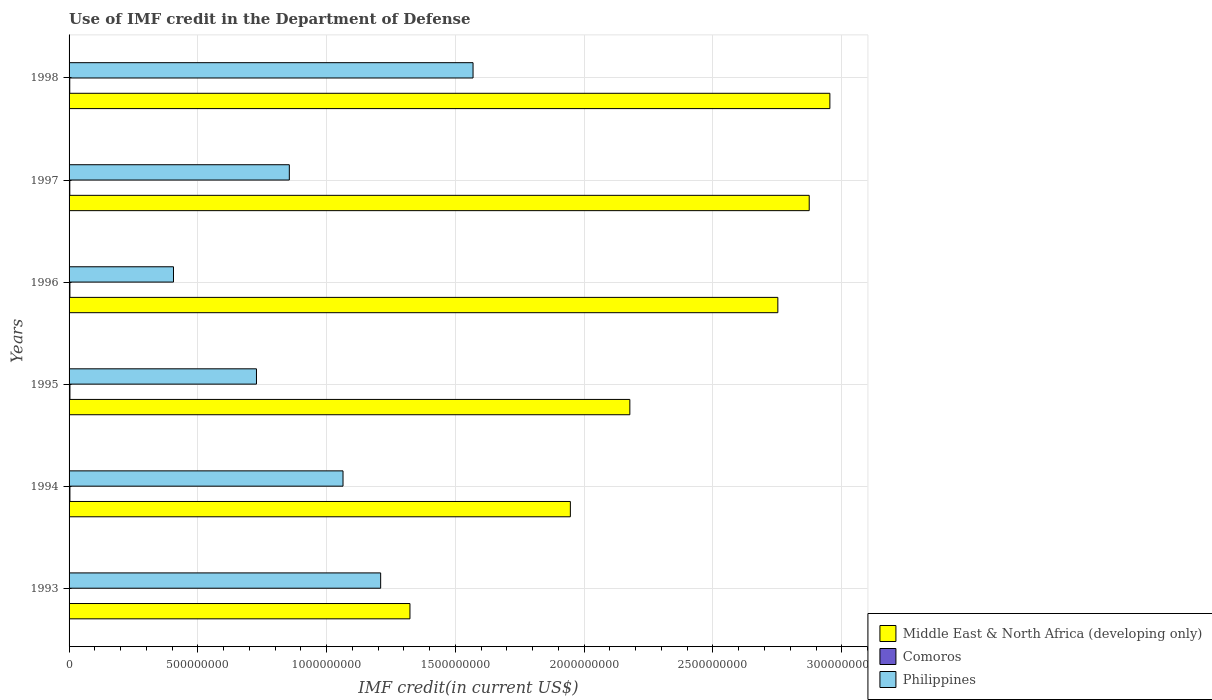How many different coloured bars are there?
Keep it short and to the point. 3. How many groups of bars are there?
Your answer should be compact. 6. Are the number of bars per tick equal to the number of legend labels?
Make the answer very short. Yes. Are the number of bars on each tick of the Y-axis equal?
Give a very brief answer. Yes. How many bars are there on the 4th tick from the top?
Your answer should be very brief. 3. In how many cases, is the number of bars for a given year not equal to the number of legend labels?
Keep it short and to the point. 0. What is the IMF credit in the Department of Defense in Comoros in 1995?
Give a very brief answer. 3.34e+06. Across all years, what is the maximum IMF credit in the Department of Defense in Philippines?
Give a very brief answer. 1.57e+09. Across all years, what is the minimum IMF credit in the Department of Defense in Middle East & North Africa (developing only)?
Keep it short and to the point. 1.32e+09. In which year was the IMF credit in the Department of Defense in Comoros minimum?
Give a very brief answer. 1993. What is the total IMF credit in the Department of Defense in Comoros in the graph?
Provide a succinct answer. 1.66e+07. What is the difference between the IMF credit in the Department of Defense in Comoros in 1995 and that in 1996?
Give a very brief answer. 1.10e+05. What is the difference between the IMF credit in the Department of Defense in Middle East & North Africa (developing only) in 1997 and the IMF credit in the Department of Defense in Philippines in 1998?
Give a very brief answer. 1.31e+09. What is the average IMF credit in the Department of Defense in Philippines per year?
Your response must be concise. 9.72e+08. In the year 1993, what is the difference between the IMF credit in the Department of Defense in Middle East & North Africa (developing only) and IMF credit in the Department of Defense in Comoros?
Your answer should be very brief. 1.32e+09. What is the ratio of the IMF credit in the Department of Defense in Philippines in 1993 to that in 1998?
Ensure brevity in your answer.  0.77. What is the difference between the highest and the second highest IMF credit in the Department of Defense in Philippines?
Make the answer very short. 3.59e+08. What is the difference between the highest and the lowest IMF credit in the Department of Defense in Philippines?
Offer a terse response. 1.16e+09. In how many years, is the IMF credit in the Department of Defense in Comoros greater than the average IMF credit in the Department of Defense in Comoros taken over all years?
Offer a terse response. 4. What does the 1st bar from the bottom in 1994 represents?
Your answer should be very brief. Middle East & North Africa (developing only). Is it the case that in every year, the sum of the IMF credit in the Department of Defense in Middle East & North Africa (developing only) and IMF credit in the Department of Defense in Comoros is greater than the IMF credit in the Department of Defense in Philippines?
Offer a very short reply. Yes. Are all the bars in the graph horizontal?
Give a very brief answer. Yes. How many years are there in the graph?
Give a very brief answer. 6. What is the difference between two consecutive major ticks on the X-axis?
Provide a short and direct response. 5.00e+08. Does the graph contain grids?
Your answer should be compact. Yes. Where does the legend appear in the graph?
Make the answer very short. Bottom right. How are the legend labels stacked?
Provide a short and direct response. Vertical. What is the title of the graph?
Your answer should be very brief. Use of IMF credit in the Department of Defense. What is the label or title of the X-axis?
Ensure brevity in your answer.  IMF credit(in current US$). What is the IMF credit(in current US$) in Middle East & North Africa (developing only) in 1993?
Your answer should be very brief. 1.32e+09. What is the IMF credit(in current US$) of Comoros in 1993?
Make the answer very short. 1.24e+06. What is the IMF credit(in current US$) of Philippines in 1993?
Ensure brevity in your answer.  1.21e+09. What is the IMF credit(in current US$) in Middle East & North Africa (developing only) in 1994?
Give a very brief answer. 1.95e+09. What is the IMF credit(in current US$) of Comoros in 1994?
Offer a terse response. 3.28e+06. What is the IMF credit(in current US$) of Philippines in 1994?
Provide a short and direct response. 1.06e+09. What is the IMF credit(in current US$) in Middle East & North Africa (developing only) in 1995?
Your response must be concise. 2.18e+09. What is the IMF credit(in current US$) in Comoros in 1995?
Keep it short and to the point. 3.34e+06. What is the IMF credit(in current US$) in Philippines in 1995?
Your response must be concise. 7.28e+08. What is the IMF credit(in current US$) in Middle East & North Africa (developing only) in 1996?
Keep it short and to the point. 2.75e+09. What is the IMF credit(in current US$) of Comoros in 1996?
Make the answer very short. 3.24e+06. What is the IMF credit(in current US$) in Philippines in 1996?
Your response must be concise. 4.05e+08. What is the IMF credit(in current US$) in Middle East & North Africa (developing only) in 1997?
Make the answer very short. 2.87e+09. What is the IMF credit(in current US$) of Comoros in 1997?
Make the answer very short. 2.79e+06. What is the IMF credit(in current US$) of Philippines in 1997?
Keep it short and to the point. 8.55e+08. What is the IMF credit(in current US$) of Middle East & North Africa (developing only) in 1998?
Offer a very short reply. 2.95e+09. What is the IMF credit(in current US$) of Comoros in 1998?
Give a very brief answer. 2.66e+06. What is the IMF credit(in current US$) of Philippines in 1998?
Your response must be concise. 1.57e+09. Across all years, what is the maximum IMF credit(in current US$) of Middle East & North Africa (developing only)?
Give a very brief answer. 2.95e+09. Across all years, what is the maximum IMF credit(in current US$) in Comoros?
Provide a succinct answer. 3.34e+06. Across all years, what is the maximum IMF credit(in current US$) of Philippines?
Keep it short and to the point. 1.57e+09. Across all years, what is the minimum IMF credit(in current US$) in Middle East & North Africa (developing only)?
Make the answer very short. 1.32e+09. Across all years, what is the minimum IMF credit(in current US$) in Comoros?
Offer a terse response. 1.24e+06. Across all years, what is the minimum IMF credit(in current US$) in Philippines?
Provide a short and direct response. 4.05e+08. What is the total IMF credit(in current US$) in Middle East & North Africa (developing only) in the graph?
Provide a succinct answer. 1.40e+1. What is the total IMF credit(in current US$) of Comoros in the graph?
Offer a very short reply. 1.66e+07. What is the total IMF credit(in current US$) in Philippines in the graph?
Keep it short and to the point. 5.83e+09. What is the difference between the IMF credit(in current US$) of Middle East & North Africa (developing only) in 1993 and that in 1994?
Keep it short and to the point. -6.23e+08. What is the difference between the IMF credit(in current US$) of Comoros in 1993 and that in 1994?
Offer a very short reply. -2.05e+06. What is the difference between the IMF credit(in current US$) of Philippines in 1993 and that in 1994?
Your answer should be very brief. 1.46e+08. What is the difference between the IMF credit(in current US$) of Middle East & North Africa (developing only) in 1993 and that in 1995?
Your answer should be very brief. -8.54e+08. What is the difference between the IMF credit(in current US$) in Comoros in 1993 and that in 1995?
Your answer should be very brief. -2.11e+06. What is the difference between the IMF credit(in current US$) of Philippines in 1993 and that in 1995?
Your answer should be very brief. 4.82e+08. What is the difference between the IMF credit(in current US$) of Middle East & North Africa (developing only) in 1993 and that in 1996?
Your answer should be compact. -1.43e+09. What is the difference between the IMF credit(in current US$) of Comoros in 1993 and that in 1996?
Offer a very short reply. -2.00e+06. What is the difference between the IMF credit(in current US$) of Philippines in 1993 and that in 1996?
Provide a short and direct response. 8.04e+08. What is the difference between the IMF credit(in current US$) in Middle East & North Africa (developing only) in 1993 and that in 1997?
Offer a very short reply. -1.55e+09. What is the difference between the IMF credit(in current US$) in Comoros in 1993 and that in 1997?
Your response must be concise. -1.56e+06. What is the difference between the IMF credit(in current US$) in Philippines in 1993 and that in 1997?
Offer a terse response. 3.55e+08. What is the difference between the IMF credit(in current US$) of Middle East & North Africa (developing only) in 1993 and that in 1998?
Provide a short and direct response. -1.63e+09. What is the difference between the IMF credit(in current US$) in Comoros in 1993 and that in 1998?
Your answer should be compact. -1.42e+06. What is the difference between the IMF credit(in current US$) in Philippines in 1993 and that in 1998?
Give a very brief answer. -3.59e+08. What is the difference between the IMF credit(in current US$) in Middle East & North Africa (developing only) in 1994 and that in 1995?
Your answer should be compact. -2.31e+08. What is the difference between the IMF credit(in current US$) in Philippines in 1994 and that in 1995?
Provide a short and direct response. 3.36e+08. What is the difference between the IMF credit(in current US$) in Middle East & North Africa (developing only) in 1994 and that in 1996?
Make the answer very short. -8.06e+08. What is the difference between the IMF credit(in current US$) in Philippines in 1994 and that in 1996?
Keep it short and to the point. 6.58e+08. What is the difference between the IMF credit(in current US$) of Middle East & North Africa (developing only) in 1994 and that in 1997?
Provide a succinct answer. -9.27e+08. What is the difference between the IMF credit(in current US$) of Comoros in 1994 and that in 1997?
Make the answer very short. 4.92e+05. What is the difference between the IMF credit(in current US$) in Philippines in 1994 and that in 1997?
Your response must be concise. 2.08e+08. What is the difference between the IMF credit(in current US$) of Middle East & North Africa (developing only) in 1994 and that in 1998?
Offer a very short reply. -1.01e+09. What is the difference between the IMF credit(in current US$) of Comoros in 1994 and that in 1998?
Provide a short and direct response. 6.24e+05. What is the difference between the IMF credit(in current US$) of Philippines in 1994 and that in 1998?
Offer a terse response. -5.05e+08. What is the difference between the IMF credit(in current US$) of Middle East & North Africa (developing only) in 1995 and that in 1996?
Your answer should be very brief. -5.75e+08. What is the difference between the IMF credit(in current US$) of Comoros in 1995 and that in 1996?
Ensure brevity in your answer.  1.10e+05. What is the difference between the IMF credit(in current US$) in Philippines in 1995 and that in 1996?
Give a very brief answer. 3.22e+08. What is the difference between the IMF credit(in current US$) of Middle East & North Africa (developing only) in 1995 and that in 1997?
Offer a very short reply. -6.96e+08. What is the difference between the IMF credit(in current US$) in Comoros in 1995 and that in 1997?
Make the answer very short. 5.52e+05. What is the difference between the IMF credit(in current US$) of Philippines in 1995 and that in 1997?
Your answer should be very brief. -1.28e+08. What is the difference between the IMF credit(in current US$) of Middle East & North Africa (developing only) in 1995 and that in 1998?
Your response must be concise. -7.77e+08. What is the difference between the IMF credit(in current US$) of Comoros in 1995 and that in 1998?
Provide a short and direct response. 6.84e+05. What is the difference between the IMF credit(in current US$) in Philippines in 1995 and that in 1998?
Your answer should be very brief. -8.41e+08. What is the difference between the IMF credit(in current US$) of Middle East & North Africa (developing only) in 1996 and that in 1997?
Provide a short and direct response. -1.22e+08. What is the difference between the IMF credit(in current US$) in Comoros in 1996 and that in 1997?
Offer a terse response. 4.42e+05. What is the difference between the IMF credit(in current US$) in Philippines in 1996 and that in 1997?
Provide a short and direct response. -4.50e+08. What is the difference between the IMF credit(in current US$) of Middle East & North Africa (developing only) in 1996 and that in 1998?
Make the answer very short. -2.02e+08. What is the difference between the IMF credit(in current US$) of Comoros in 1996 and that in 1998?
Your response must be concise. 5.74e+05. What is the difference between the IMF credit(in current US$) in Philippines in 1996 and that in 1998?
Make the answer very short. -1.16e+09. What is the difference between the IMF credit(in current US$) in Middle East & North Africa (developing only) in 1997 and that in 1998?
Your answer should be compact. -8.02e+07. What is the difference between the IMF credit(in current US$) of Comoros in 1997 and that in 1998?
Offer a terse response. 1.32e+05. What is the difference between the IMF credit(in current US$) in Philippines in 1997 and that in 1998?
Your answer should be very brief. -7.13e+08. What is the difference between the IMF credit(in current US$) in Middle East & North Africa (developing only) in 1993 and the IMF credit(in current US$) in Comoros in 1994?
Provide a succinct answer. 1.32e+09. What is the difference between the IMF credit(in current US$) of Middle East & North Africa (developing only) in 1993 and the IMF credit(in current US$) of Philippines in 1994?
Your answer should be compact. 2.60e+08. What is the difference between the IMF credit(in current US$) of Comoros in 1993 and the IMF credit(in current US$) of Philippines in 1994?
Give a very brief answer. -1.06e+09. What is the difference between the IMF credit(in current US$) in Middle East & North Africa (developing only) in 1993 and the IMF credit(in current US$) in Comoros in 1995?
Offer a very short reply. 1.32e+09. What is the difference between the IMF credit(in current US$) in Middle East & North Africa (developing only) in 1993 and the IMF credit(in current US$) in Philippines in 1995?
Your answer should be very brief. 5.96e+08. What is the difference between the IMF credit(in current US$) in Comoros in 1993 and the IMF credit(in current US$) in Philippines in 1995?
Offer a very short reply. -7.26e+08. What is the difference between the IMF credit(in current US$) in Middle East & North Africa (developing only) in 1993 and the IMF credit(in current US$) in Comoros in 1996?
Keep it short and to the point. 1.32e+09. What is the difference between the IMF credit(in current US$) of Middle East & North Africa (developing only) in 1993 and the IMF credit(in current US$) of Philippines in 1996?
Offer a terse response. 9.18e+08. What is the difference between the IMF credit(in current US$) of Comoros in 1993 and the IMF credit(in current US$) of Philippines in 1996?
Give a very brief answer. -4.04e+08. What is the difference between the IMF credit(in current US$) in Middle East & North Africa (developing only) in 1993 and the IMF credit(in current US$) in Comoros in 1997?
Keep it short and to the point. 1.32e+09. What is the difference between the IMF credit(in current US$) in Middle East & North Africa (developing only) in 1993 and the IMF credit(in current US$) in Philippines in 1997?
Give a very brief answer. 4.68e+08. What is the difference between the IMF credit(in current US$) in Comoros in 1993 and the IMF credit(in current US$) in Philippines in 1997?
Your answer should be very brief. -8.54e+08. What is the difference between the IMF credit(in current US$) in Middle East & North Africa (developing only) in 1993 and the IMF credit(in current US$) in Comoros in 1998?
Keep it short and to the point. 1.32e+09. What is the difference between the IMF credit(in current US$) of Middle East & North Africa (developing only) in 1993 and the IMF credit(in current US$) of Philippines in 1998?
Ensure brevity in your answer.  -2.45e+08. What is the difference between the IMF credit(in current US$) in Comoros in 1993 and the IMF credit(in current US$) in Philippines in 1998?
Make the answer very short. -1.57e+09. What is the difference between the IMF credit(in current US$) in Middle East & North Africa (developing only) in 1994 and the IMF credit(in current US$) in Comoros in 1995?
Your response must be concise. 1.94e+09. What is the difference between the IMF credit(in current US$) in Middle East & North Africa (developing only) in 1994 and the IMF credit(in current US$) in Philippines in 1995?
Your answer should be very brief. 1.22e+09. What is the difference between the IMF credit(in current US$) in Comoros in 1994 and the IMF credit(in current US$) in Philippines in 1995?
Offer a terse response. -7.24e+08. What is the difference between the IMF credit(in current US$) of Middle East & North Africa (developing only) in 1994 and the IMF credit(in current US$) of Comoros in 1996?
Give a very brief answer. 1.94e+09. What is the difference between the IMF credit(in current US$) of Middle East & North Africa (developing only) in 1994 and the IMF credit(in current US$) of Philippines in 1996?
Provide a succinct answer. 1.54e+09. What is the difference between the IMF credit(in current US$) in Comoros in 1994 and the IMF credit(in current US$) in Philippines in 1996?
Give a very brief answer. -4.02e+08. What is the difference between the IMF credit(in current US$) in Middle East & North Africa (developing only) in 1994 and the IMF credit(in current US$) in Comoros in 1997?
Provide a short and direct response. 1.94e+09. What is the difference between the IMF credit(in current US$) of Middle East & North Africa (developing only) in 1994 and the IMF credit(in current US$) of Philippines in 1997?
Give a very brief answer. 1.09e+09. What is the difference between the IMF credit(in current US$) in Comoros in 1994 and the IMF credit(in current US$) in Philippines in 1997?
Offer a terse response. -8.52e+08. What is the difference between the IMF credit(in current US$) in Middle East & North Africa (developing only) in 1994 and the IMF credit(in current US$) in Comoros in 1998?
Your answer should be very brief. 1.94e+09. What is the difference between the IMF credit(in current US$) in Middle East & North Africa (developing only) in 1994 and the IMF credit(in current US$) in Philippines in 1998?
Offer a terse response. 3.78e+08. What is the difference between the IMF credit(in current US$) of Comoros in 1994 and the IMF credit(in current US$) of Philippines in 1998?
Your answer should be compact. -1.57e+09. What is the difference between the IMF credit(in current US$) of Middle East & North Africa (developing only) in 1995 and the IMF credit(in current US$) of Comoros in 1996?
Ensure brevity in your answer.  2.17e+09. What is the difference between the IMF credit(in current US$) in Middle East & North Africa (developing only) in 1995 and the IMF credit(in current US$) in Philippines in 1996?
Provide a short and direct response. 1.77e+09. What is the difference between the IMF credit(in current US$) of Comoros in 1995 and the IMF credit(in current US$) of Philippines in 1996?
Your answer should be very brief. -4.02e+08. What is the difference between the IMF credit(in current US$) of Middle East & North Africa (developing only) in 1995 and the IMF credit(in current US$) of Comoros in 1997?
Provide a short and direct response. 2.17e+09. What is the difference between the IMF credit(in current US$) in Middle East & North Africa (developing only) in 1995 and the IMF credit(in current US$) in Philippines in 1997?
Give a very brief answer. 1.32e+09. What is the difference between the IMF credit(in current US$) of Comoros in 1995 and the IMF credit(in current US$) of Philippines in 1997?
Offer a very short reply. -8.52e+08. What is the difference between the IMF credit(in current US$) in Middle East & North Africa (developing only) in 1995 and the IMF credit(in current US$) in Comoros in 1998?
Your answer should be compact. 2.17e+09. What is the difference between the IMF credit(in current US$) of Middle East & North Africa (developing only) in 1995 and the IMF credit(in current US$) of Philippines in 1998?
Give a very brief answer. 6.09e+08. What is the difference between the IMF credit(in current US$) in Comoros in 1995 and the IMF credit(in current US$) in Philippines in 1998?
Your answer should be very brief. -1.57e+09. What is the difference between the IMF credit(in current US$) in Middle East & North Africa (developing only) in 1996 and the IMF credit(in current US$) in Comoros in 1997?
Give a very brief answer. 2.75e+09. What is the difference between the IMF credit(in current US$) in Middle East & North Africa (developing only) in 1996 and the IMF credit(in current US$) in Philippines in 1997?
Your answer should be very brief. 1.90e+09. What is the difference between the IMF credit(in current US$) of Comoros in 1996 and the IMF credit(in current US$) of Philippines in 1997?
Provide a succinct answer. -8.52e+08. What is the difference between the IMF credit(in current US$) of Middle East & North Africa (developing only) in 1996 and the IMF credit(in current US$) of Comoros in 1998?
Your answer should be compact. 2.75e+09. What is the difference between the IMF credit(in current US$) of Middle East & North Africa (developing only) in 1996 and the IMF credit(in current US$) of Philippines in 1998?
Ensure brevity in your answer.  1.18e+09. What is the difference between the IMF credit(in current US$) in Comoros in 1996 and the IMF credit(in current US$) in Philippines in 1998?
Your response must be concise. -1.57e+09. What is the difference between the IMF credit(in current US$) of Middle East & North Africa (developing only) in 1997 and the IMF credit(in current US$) of Comoros in 1998?
Make the answer very short. 2.87e+09. What is the difference between the IMF credit(in current US$) in Middle East & North Africa (developing only) in 1997 and the IMF credit(in current US$) in Philippines in 1998?
Provide a short and direct response. 1.31e+09. What is the difference between the IMF credit(in current US$) in Comoros in 1997 and the IMF credit(in current US$) in Philippines in 1998?
Your response must be concise. -1.57e+09. What is the average IMF credit(in current US$) of Middle East & North Africa (developing only) per year?
Provide a succinct answer. 2.34e+09. What is the average IMF credit(in current US$) of Comoros per year?
Your answer should be very brief. 2.76e+06. What is the average IMF credit(in current US$) of Philippines per year?
Keep it short and to the point. 9.72e+08. In the year 1993, what is the difference between the IMF credit(in current US$) of Middle East & North Africa (developing only) and IMF credit(in current US$) of Comoros?
Offer a very short reply. 1.32e+09. In the year 1993, what is the difference between the IMF credit(in current US$) of Middle East & North Africa (developing only) and IMF credit(in current US$) of Philippines?
Ensure brevity in your answer.  1.14e+08. In the year 1993, what is the difference between the IMF credit(in current US$) of Comoros and IMF credit(in current US$) of Philippines?
Your answer should be very brief. -1.21e+09. In the year 1994, what is the difference between the IMF credit(in current US$) of Middle East & North Africa (developing only) and IMF credit(in current US$) of Comoros?
Keep it short and to the point. 1.94e+09. In the year 1994, what is the difference between the IMF credit(in current US$) in Middle East & North Africa (developing only) and IMF credit(in current US$) in Philippines?
Provide a short and direct response. 8.83e+08. In the year 1994, what is the difference between the IMF credit(in current US$) in Comoros and IMF credit(in current US$) in Philippines?
Give a very brief answer. -1.06e+09. In the year 1995, what is the difference between the IMF credit(in current US$) in Middle East & North Africa (developing only) and IMF credit(in current US$) in Comoros?
Provide a succinct answer. 2.17e+09. In the year 1995, what is the difference between the IMF credit(in current US$) in Middle East & North Africa (developing only) and IMF credit(in current US$) in Philippines?
Offer a terse response. 1.45e+09. In the year 1995, what is the difference between the IMF credit(in current US$) in Comoros and IMF credit(in current US$) in Philippines?
Offer a very short reply. -7.24e+08. In the year 1996, what is the difference between the IMF credit(in current US$) of Middle East & North Africa (developing only) and IMF credit(in current US$) of Comoros?
Provide a succinct answer. 2.75e+09. In the year 1996, what is the difference between the IMF credit(in current US$) in Middle East & North Africa (developing only) and IMF credit(in current US$) in Philippines?
Make the answer very short. 2.35e+09. In the year 1996, what is the difference between the IMF credit(in current US$) in Comoros and IMF credit(in current US$) in Philippines?
Keep it short and to the point. -4.02e+08. In the year 1997, what is the difference between the IMF credit(in current US$) in Middle East & North Africa (developing only) and IMF credit(in current US$) in Comoros?
Offer a terse response. 2.87e+09. In the year 1997, what is the difference between the IMF credit(in current US$) of Middle East & North Africa (developing only) and IMF credit(in current US$) of Philippines?
Ensure brevity in your answer.  2.02e+09. In the year 1997, what is the difference between the IMF credit(in current US$) of Comoros and IMF credit(in current US$) of Philippines?
Your answer should be compact. -8.52e+08. In the year 1998, what is the difference between the IMF credit(in current US$) in Middle East & North Africa (developing only) and IMF credit(in current US$) in Comoros?
Your answer should be very brief. 2.95e+09. In the year 1998, what is the difference between the IMF credit(in current US$) in Middle East & North Africa (developing only) and IMF credit(in current US$) in Philippines?
Your answer should be very brief. 1.39e+09. In the year 1998, what is the difference between the IMF credit(in current US$) of Comoros and IMF credit(in current US$) of Philippines?
Keep it short and to the point. -1.57e+09. What is the ratio of the IMF credit(in current US$) of Middle East & North Africa (developing only) in 1993 to that in 1994?
Make the answer very short. 0.68. What is the ratio of the IMF credit(in current US$) of Comoros in 1993 to that in 1994?
Give a very brief answer. 0.38. What is the ratio of the IMF credit(in current US$) in Philippines in 1993 to that in 1994?
Your answer should be compact. 1.14. What is the ratio of the IMF credit(in current US$) of Middle East & North Africa (developing only) in 1993 to that in 1995?
Provide a short and direct response. 0.61. What is the ratio of the IMF credit(in current US$) of Comoros in 1993 to that in 1995?
Provide a short and direct response. 0.37. What is the ratio of the IMF credit(in current US$) in Philippines in 1993 to that in 1995?
Give a very brief answer. 1.66. What is the ratio of the IMF credit(in current US$) in Middle East & North Africa (developing only) in 1993 to that in 1996?
Ensure brevity in your answer.  0.48. What is the ratio of the IMF credit(in current US$) of Comoros in 1993 to that in 1996?
Provide a succinct answer. 0.38. What is the ratio of the IMF credit(in current US$) in Philippines in 1993 to that in 1996?
Make the answer very short. 2.98. What is the ratio of the IMF credit(in current US$) of Middle East & North Africa (developing only) in 1993 to that in 1997?
Make the answer very short. 0.46. What is the ratio of the IMF credit(in current US$) of Comoros in 1993 to that in 1997?
Offer a very short reply. 0.44. What is the ratio of the IMF credit(in current US$) of Philippines in 1993 to that in 1997?
Make the answer very short. 1.41. What is the ratio of the IMF credit(in current US$) of Middle East & North Africa (developing only) in 1993 to that in 1998?
Keep it short and to the point. 0.45. What is the ratio of the IMF credit(in current US$) in Comoros in 1993 to that in 1998?
Keep it short and to the point. 0.46. What is the ratio of the IMF credit(in current US$) in Philippines in 1993 to that in 1998?
Ensure brevity in your answer.  0.77. What is the ratio of the IMF credit(in current US$) in Middle East & North Africa (developing only) in 1994 to that in 1995?
Keep it short and to the point. 0.89. What is the ratio of the IMF credit(in current US$) in Comoros in 1994 to that in 1995?
Ensure brevity in your answer.  0.98. What is the ratio of the IMF credit(in current US$) in Philippines in 1994 to that in 1995?
Keep it short and to the point. 1.46. What is the ratio of the IMF credit(in current US$) of Middle East & North Africa (developing only) in 1994 to that in 1996?
Offer a very short reply. 0.71. What is the ratio of the IMF credit(in current US$) of Comoros in 1994 to that in 1996?
Ensure brevity in your answer.  1.02. What is the ratio of the IMF credit(in current US$) of Philippines in 1994 to that in 1996?
Make the answer very short. 2.62. What is the ratio of the IMF credit(in current US$) of Middle East & North Africa (developing only) in 1994 to that in 1997?
Your answer should be compact. 0.68. What is the ratio of the IMF credit(in current US$) in Comoros in 1994 to that in 1997?
Provide a succinct answer. 1.18. What is the ratio of the IMF credit(in current US$) of Philippines in 1994 to that in 1997?
Your response must be concise. 1.24. What is the ratio of the IMF credit(in current US$) in Middle East & North Africa (developing only) in 1994 to that in 1998?
Ensure brevity in your answer.  0.66. What is the ratio of the IMF credit(in current US$) in Comoros in 1994 to that in 1998?
Provide a succinct answer. 1.23. What is the ratio of the IMF credit(in current US$) in Philippines in 1994 to that in 1998?
Ensure brevity in your answer.  0.68. What is the ratio of the IMF credit(in current US$) of Middle East & North Africa (developing only) in 1995 to that in 1996?
Give a very brief answer. 0.79. What is the ratio of the IMF credit(in current US$) in Comoros in 1995 to that in 1996?
Offer a terse response. 1.03. What is the ratio of the IMF credit(in current US$) in Philippines in 1995 to that in 1996?
Provide a succinct answer. 1.79. What is the ratio of the IMF credit(in current US$) in Middle East & North Africa (developing only) in 1995 to that in 1997?
Give a very brief answer. 0.76. What is the ratio of the IMF credit(in current US$) of Comoros in 1995 to that in 1997?
Offer a terse response. 1.2. What is the ratio of the IMF credit(in current US$) in Philippines in 1995 to that in 1997?
Your response must be concise. 0.85. What is the ratio of the IMF credit(in current US$) of Middle East & North Africa (developing only) in 1995 to that in 1998?
Your response must be concise. 0.74. What is the ratio of the IMF credit(in current US$) of Comoros in 1995 to that in 1998?
Your response must be concise. 1.26. What is the ratio of the IMF credit(in current US$) in Philippines in 1995 to that in 1998?
Your answer should be compact. 0.46. What is the ratio of the IMF credit(in current US$) of Middle East & North Africa (developing only) in 1996 to that in 1997?
Your answer should be compact. 0.96. What is the ratio of the IMF credit(in current US$) of Comoros in 1996 to that in 1997?
Ensure brevity in your answer.  1.16. What is the ratio of the IMF credit(in current US$) of Philippines in 1996 to that in 1997?
Keep it short and to the point. 0.47. What is the ratio of the IMF credit(in current US$) of Middle East & North Africa (developing only) in 1996 to that in 1998?
Your answer should be very brief. 0.93. What is the ratio of the IMF credit(in current US$) of Comoros in 1996 to that in 1998?
Your answer should be very brief. 1.22. What is the ratio of the IMF credit(in current US$) of Philippines in 1996 to that in 1998?
Provide a short and direct response. 0.26. What is the ratio of the IMF credit(in current US$) in Middle East & North Africa (developing only) in 1997 to that in 1998?
Provide a short and direct response. 0.97. What is the ratio of the IMF credit(in current US$) in Comoros in 1997 to that in 1998?
Your answer should be very brief. 1.05. What is the ratio of the IMF credit(in current US$) in Philippines in 1997 to that in 1998?
Your response must be concise. 0.55. What is the difference between the highest and the second highest IMF credit(in current US$) of Middle East & North Africa (developing only)?
Provide a short and direct response. 8.02e+07. What is the difference between the highest and the second highest IMF credit(in current US$) of Comoros?
Provide a short and direct response. 6.00e+04. What is the difference between the highest and the second highest IMF credit(in current US$) of Philippines?
Ensure brevity in your answer.  3.59e+08. What is the difference between the highest and the lowest IMF credit(in current US$) of Middle East & North Africa (developing only)?
Provide a succinct answer. 1.63e+09. What is the difference between the highest and the lowest IMF credit(in current US$) of Comoros?
Give a very brief answer. 2.11e+06. What is the difference between the highest and the lowest IMF credit(in current US$) in Philippines?
Ensure brevity in your answer.  1.16e+09. 